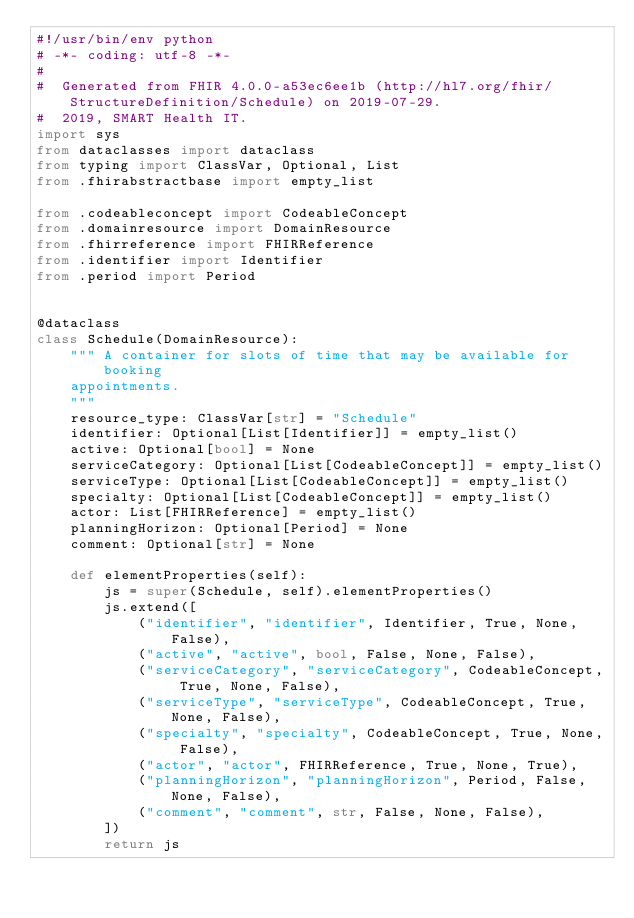Convert code to text. <code><loc_0><loc_0><loc_500><loc_500><_Python_>#!/usr/bin/env python
# -*- coding: utf-8 -*-
#
#  Generated from FHIR 4.0.0-a53ec6ee1b (http://hl7.org/fhir/StructureDefinition/Schedule) on 2019-07-29.
#  2019, SMART Health IT.
import sys
from dataclasses import dataclass
from typing import ClassVar, Optional, List
from .fhirabstractbase import empty_list

from .codeableconcept import CodeableConcept
from .domainresource import DomainResource
from .fhirreference import FHIRReference
from .identifier import Identifier
from .period import Period


@dataclass
class Schedule(DomainResource):
    """ A container for slots of time that may be available for booking
    appointments.
    """
    resource_type: ClassVar[str] = "Schedule"
    identifier: Optional[List[Identifier]] = empty_list()
    active: Optional[bool] = None
    serviceCategory: Optional[List[CodeableConcept]] = empty_list()
    serviceType: Optional[List[CodeableConcept]] = empty_list()
    specialty: Optional[List[CodeableConcept]] = empty_list()
    actor: List[FHIRReference] = empty_list()
    planningHorizon: Optional[Period] = None
    comment: Optional[str] = None

    def elementProperties(self):
        js = super(Schedule, self).elementProperties()
        js.extend([
            ("identifier", "identifier", Identifier, True, None, False),
            ("active", "active", bool, False, None, False),
            ("serviceCategory", "serviceCategory", CodeableConcept, True, None, False),
            ("serviceType", "serviceType", CodeableConcept, True, None, False),
            ("specialty", "specialty", CodeableConcept, True, None, False),
            ("actor", "actor", FHIRReference, True, None, True),
            ("planningHorizon", "planningHorizon", Period, False, None, False),
            ("comment", "comment", str, False, None, False),
        ])
        return js</code> 